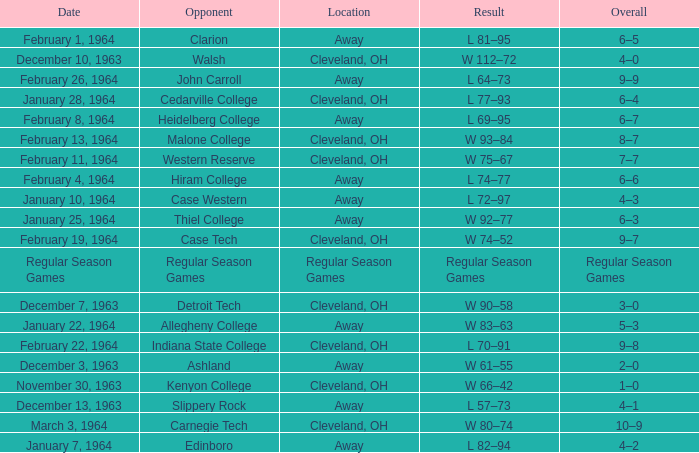What is the Location with a Date that is december 10, 1963? Cleveland, OH. 